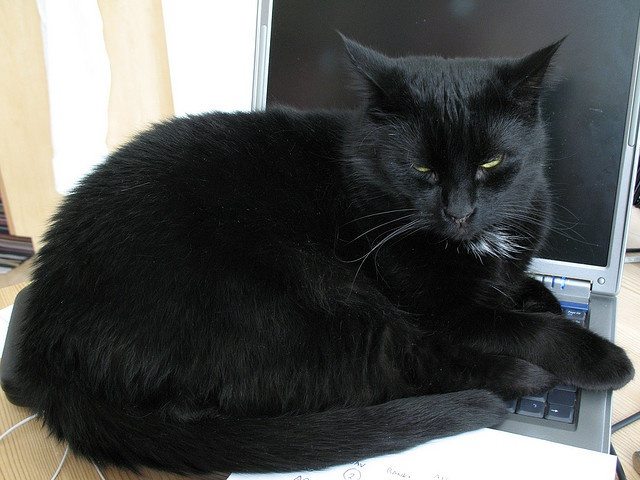Describe the objects in this image and their specific colors. I can see cat in black, beige, gray, purple, and white tones and laptop in beige, black, gray, purple, and lightgray tones in this image. 